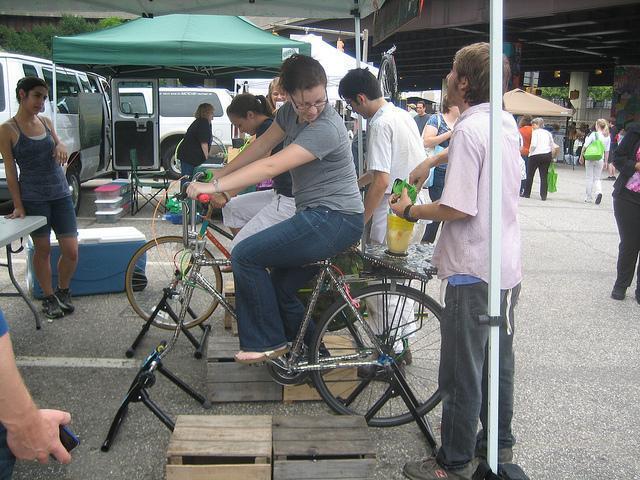How many tires does the bike in the forefront have?
Give a very brief answer. 1. How many trucks are in the picture?
Give a very brief answer. 1. How many people are there?
Give a very brief answer. 9. How many bicycles are in the picture?
Give a very brief answer. 2. How many dining tables are there?
Give a very brief answer. 1. How many laptops are there?
Give a very brief answer. 0. 